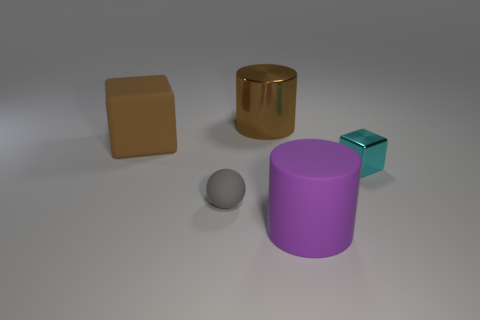How many other things are the same shape as the large purple thing?
Make the answer very short. 1. How many big metal things are in front of the big metallic cylinder that is right of the large matte thing left of the big rubber cylinder?
Offer a terse response. 0. How many large brown rubber objects are right of the metal object behind the metal block?
Your answer should be very brief. 0. There is a large rubber cylinder; what number of cyan things are in front of it?
Provide a short and direct response. 0. What number of other objects are there of the same size as the matte block?
Provide a succinct answer. 2. What size is the other object that is the same shape as the purple object?
Keep it short and to the point. Large. The tiny thing that is right of the purple matte cylinder has what shape?
Provide a short and direct response. Cube. What color is the large cylinder that is right of the big cylinder behind the rubber ball?
Your answer should be compact. Purple. How many things are either big cylinders that are behind the metal cube or rubber spheres?
Make the answer very short. 2. Does the gray matte object have the same size as the block that is to the right of the large brown matte object?
Offer a terse response. Yes. 